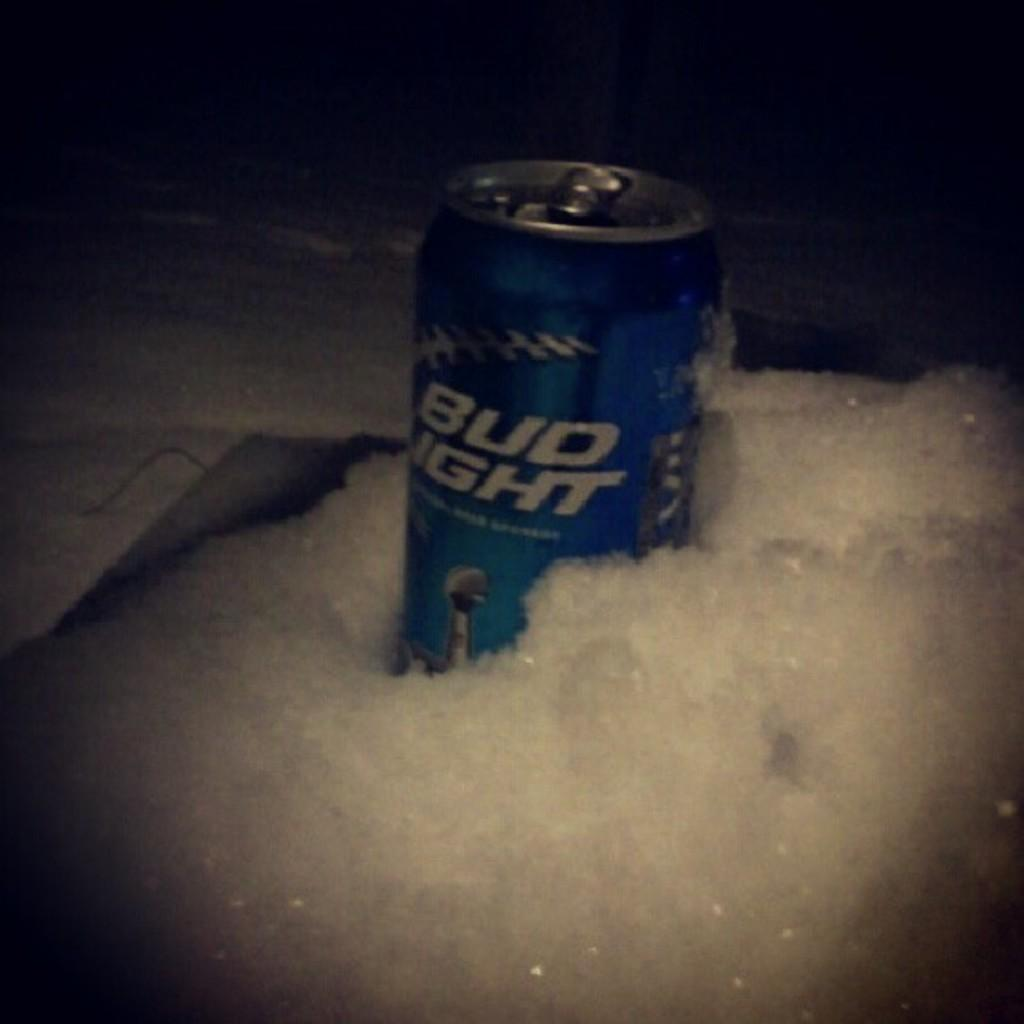Provide a one-sentence caption for the provided image. An open can of Bud light sits in the snow. 